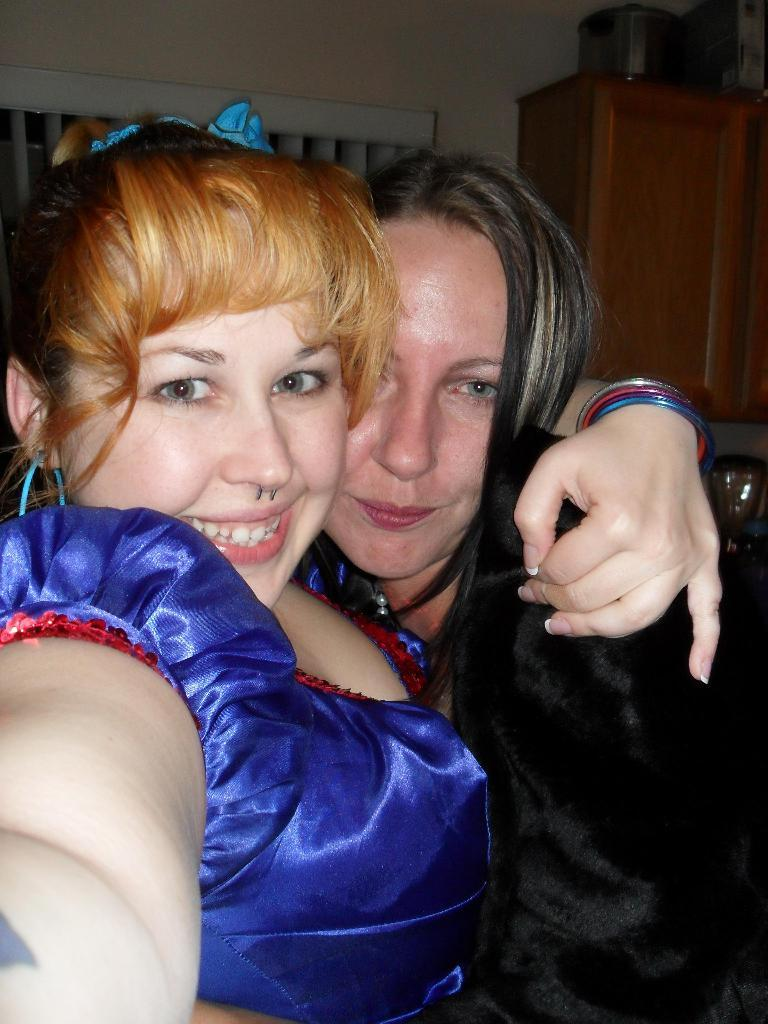How many people are in the image? There are two women in the image. What is the facial expression of the women? The women are smiling. What is on the wall behind the women? There is a curtain on the wall behind the women. What can be seen on the wooden cupboard beside the curtain? There is an object on the wooden cupboard beside the curtain. What type of shirt is the woman on the left wearing in the image? There is no shirt visible in the image, as the women are wearing dresses. How many beds are in the image? There are no beds present in the image. 